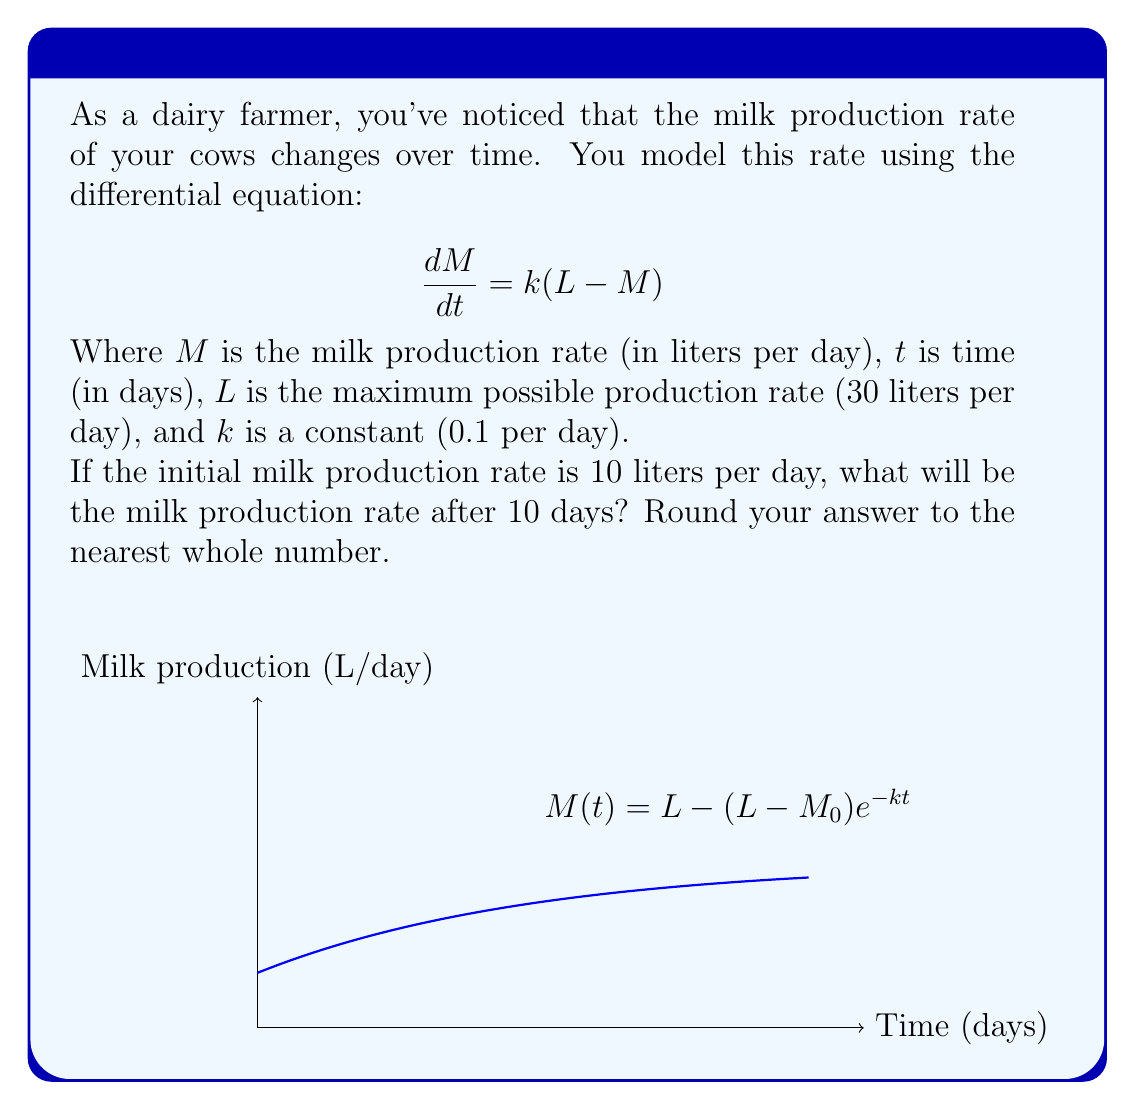Show me your answer to this math problem. Let's solve this step-by-step:

1) The general solution for this type of differential equation is:

   $$M(t) = L - (L-M_0)e^{-kt}$$

   Where $M_0$ is the initial milk production rate.

2) We're given:
   - $L = 30$ liters/day
   - $k = 0.1$ per day
   - $M_0 = 10$ liters/day
   - $t = 10$ days

3) Let's substitute these values into our equation:

   $$M(10) = 30 - (30-10)e^{-0.1(10)}$$

4) Simplify:
   $$M(10) = 30 - 20e^{-1}$$

5) Calculate $e^{-1}$ (approximately 0.3679):
   $$M(10) = 30 - 20(0.3679)$$

6) Compute:
   $$M(10) = 30 - 7.358 = 22.642$$

7) Rounding to the nearest whole number:
   $$M(10) \approx 23$$ liters/day
Answer: 23 liters/day 